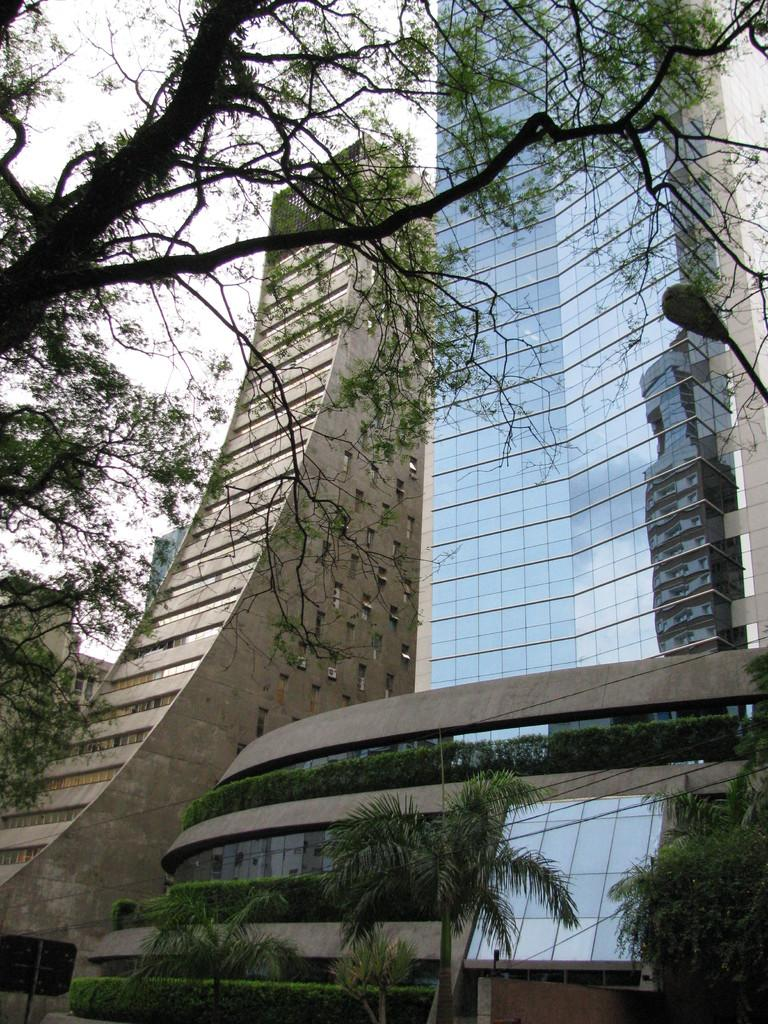What structures are present in the image? There are buildings in the image. What type of vegetation is visible in the image? There are trees in the image. What part of the natural environment is visible in the image? The sky is visible in the background of the image. How does the air help the beginner brain in the image? There is no mention of air, beginner, or brain in the image, so it is not possible to answer that question. 